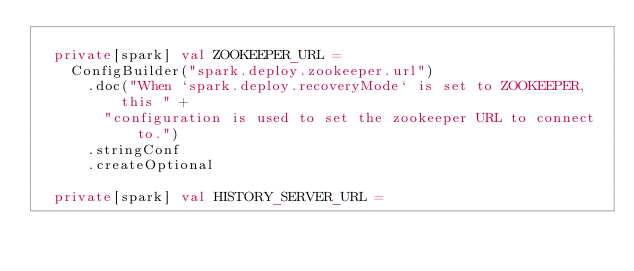<code> <loc_0><loc_0><loc_500><loc_500><_Scala_>
  private[spark] val ZOOKEEPER_URL =
    ConfigBuilder("spark.deploy.zookeeper.url")
      .doc("When `spark.deploy.recoveryMode` is set to ZOOKEEPER, this " +
        "configuration is used to set the zookeeper URL to connect to.")
      .stringConf
      .createOptional

  private[spark] val HISTORY_SERVER_URL =</code> 